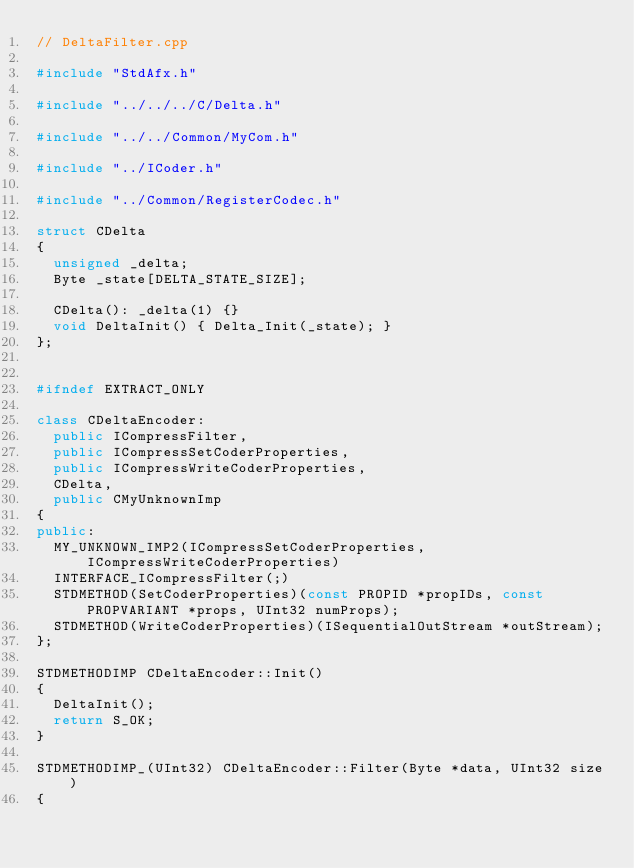Convert code to text. <code><loc_0><loc_0><loc_500><loc_500><_C++_>// DeltaFilter.cpp

#include "StdAfx.h"

#include "../../../C/Delta.h"

#include "../../Common/MyCom.h"

#include "../ICoder.h"

#include "../Common/RegisterCodec.h"

struct CDelta
{
  unsigned _delta;
  Byte _state[DELTA_STATE_SIZE];

  CDelta(): _delta(1) {}
  void DeltaInit() { Delta_Init(_state); }
};


#ifndef EXTRACT_ONLY

class CDeltaEncoder:
  public ICompressFilter,
  public ICompressSetCoderProperties,
  public ICompressWriteCoderProperties,
  CDelta,
  public CMyUnknownImp
{
public:
  MY_UNKNOWN_IMP2(ICompressSetCoderProperties, ICompressWriteCoderProperties)
  INTERFACE_ICompressFilter(;)
  STDMETHOD(SetCoderProperties)(const PROPID *propIDs, const PROPVARIANT *props, UInt32 numProps);
  STDMETHOD(WriteCoderProperties)(ISequentialOutStream *outStream);
};

STDMETHODIMP CDeltaEncoder::Init()
{
  DeltaInit();
  return S_OK;
}

STDMETHODIMP_(UInt32) CDeltaEncoder::Filter(Byte *data, UInt32 size)
{</code> 